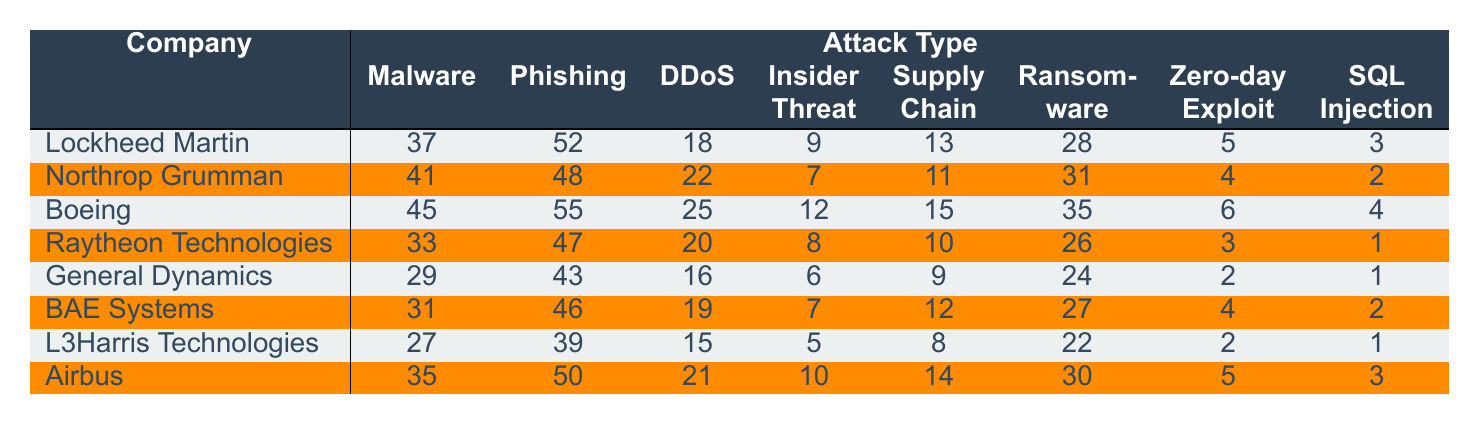What is the total number of incidents reported for Boeing? To find the total incidents for Boeing, sum all the values in Boeing's row: (45 + 55 + 25 + 12 + 15 + 35 + 6 + 4) = 197.
Answer: 197 Which company experienced the most incidents due to Phishing? Looking at the Phishing column, the highest value is 55, which belongs to Boeing.
Answer: Boeing What is the average number of Ransomware incidents across all companies? Sum all Ransomware incidents: (28 + 31 + 35 + 26 + 24 + 27 + 22 + 30) = 229. There are 8 companies, so the average is 229/8 = 28.625.
Answer: 28.63 Did Northrop Grumman have more SQL Injection incidents than BAE Systems? Northrop Grumman had 2 SQL Injection incidents while BAE Systems had 2 as well. Since they are equal, the answer is no.
Answer: No Which attack type had the lowest number of incidents for Lockheed Martin? The lowest number of incidents is 3 for SQL Injection in Lockheed Martin's row.
Answer: SQL Injection What is the difference in the number of DDoS incidents between Airbus and General Dynamics? Airbus had 21 DDoS incidents and General Dynamics had 16, thus the difference is 21 - 16 = 5.
Answer: 5 Which company had the fewest incidents overall, and what was the total number? To find the fewest incidents, sum each company's incidents and compare. Lockheed Martin has a total of 37 + 52 + 18 + 9 + 13 + 28 + 5 + 3 = 165, which is the lowest.
Answer: Lockheed Martin, 165 What is the total number of Insider Threat incidents across all companies? Sum the values in the Insider Threat column: (9 + 7 + 12 + 8 + 6 + 7 + 5 + 10) = 64.
Answer: 64 Which company had a higher number of incidents: L3Harris Technologies in Ransomware or Raytheon Technologies in DDoS? L3Harris Technologies had 22 Ransomware incidents, while Raytheon Technologies had 20 DDoS incidents. Since 22 > 20, L3Harris Technologies had a higher number.
Answer: L3Harris Technologies Is the total number of incidents for all companies greater than 350? To determine this, sum all incidents for each company: (37 + 52 + 18 + 9 + 13 + 28 + 5 + 3) + (41 + 48 + 22 + 7 + 11 + 31 + 4 + 2) + (45 + 55 + 25 + 12 + 15 + 35 + 6 + 4) + (33 + 47 + 20 + 8 + 10 + 26 + 3 + 1) + (29 + 43 + 16 + 6 + 9 + 24 + 2 + 1) + (31 + 46 + 19 + 7 + 12 + 27 + 4 + 2) + (27 + 39 + 15 + 5 + 8 + 22 + 2 + 1) + (35 + 50 + 21 + 10 + 14 + 30 + 5 + 3) = 403. Since 403 > 350, the answer is yes.
Answer: Yes 